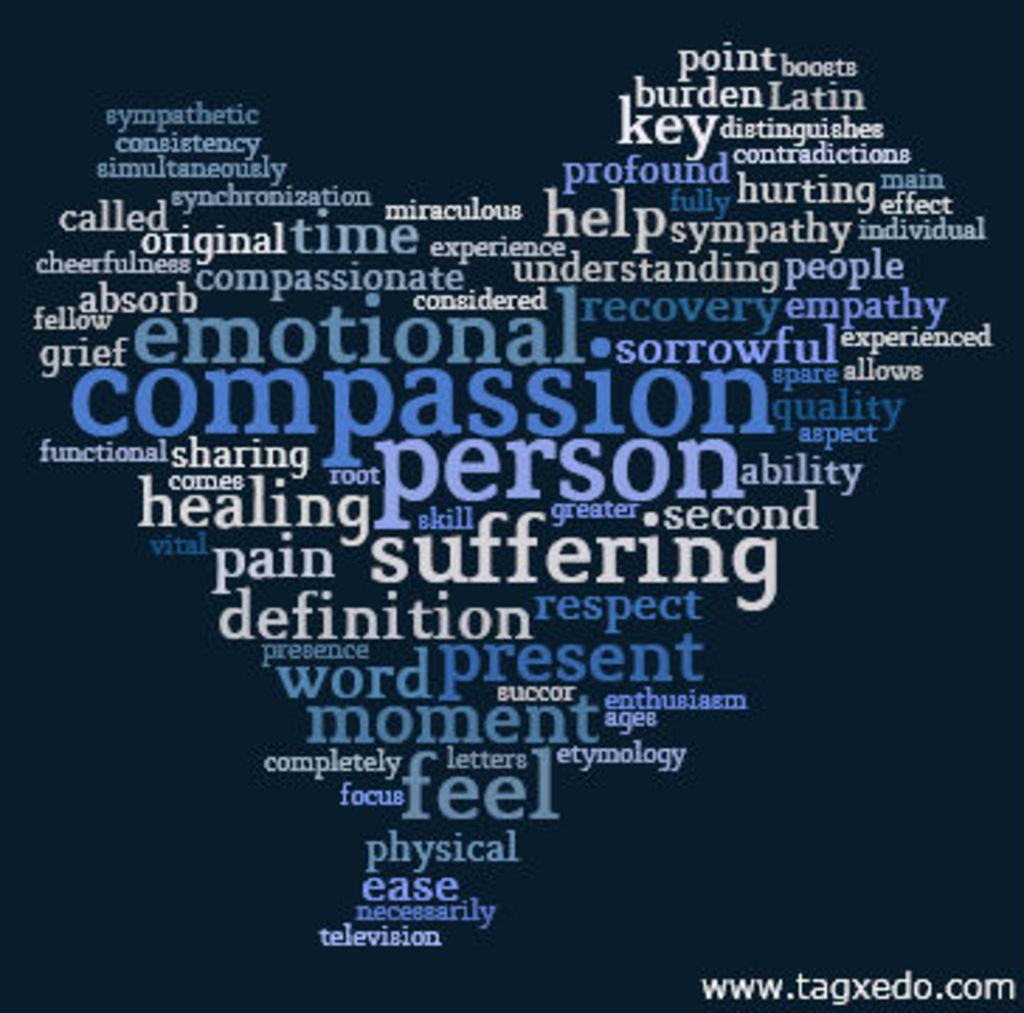Where is this emotional post from?
Provide a succinct answer. Www.tagxedo.com. What are the four largest words shown?
Provide a succinct answer. Emotional compassion person suffering. 